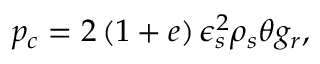Convert formula to latex. <formula><loc_0><loc_0><loc_500><loc_500>p _ { c } = 2 \left ( 1 + e \right ) \epsilon _ { s } ^ { 2 } \rho _ { s } \theta g _ { r } ,</formula> 